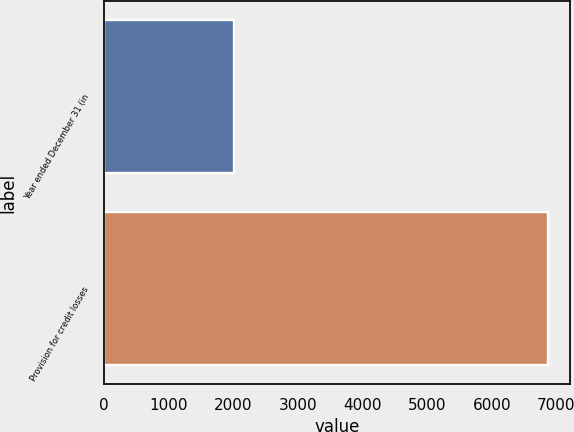Convert chart. <chart><loc_0><loc_0><loc_500><loc_500><bar_chart><fcel>Year ended December 31 (in<fcel>Provision for credit losses<nl><fcel>2007<fcel>6864<nl></chart> 